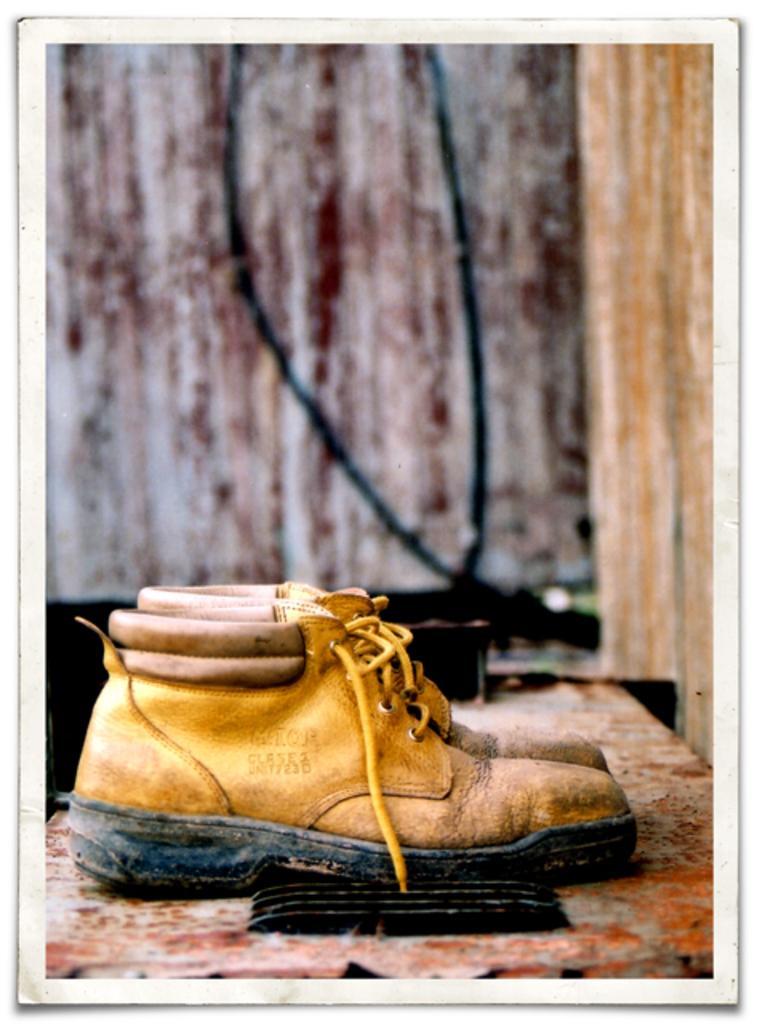Describe this image in one or two sentences. In this image we can see a pair of shoes is kept on the surface. The background of the image is blurred. 